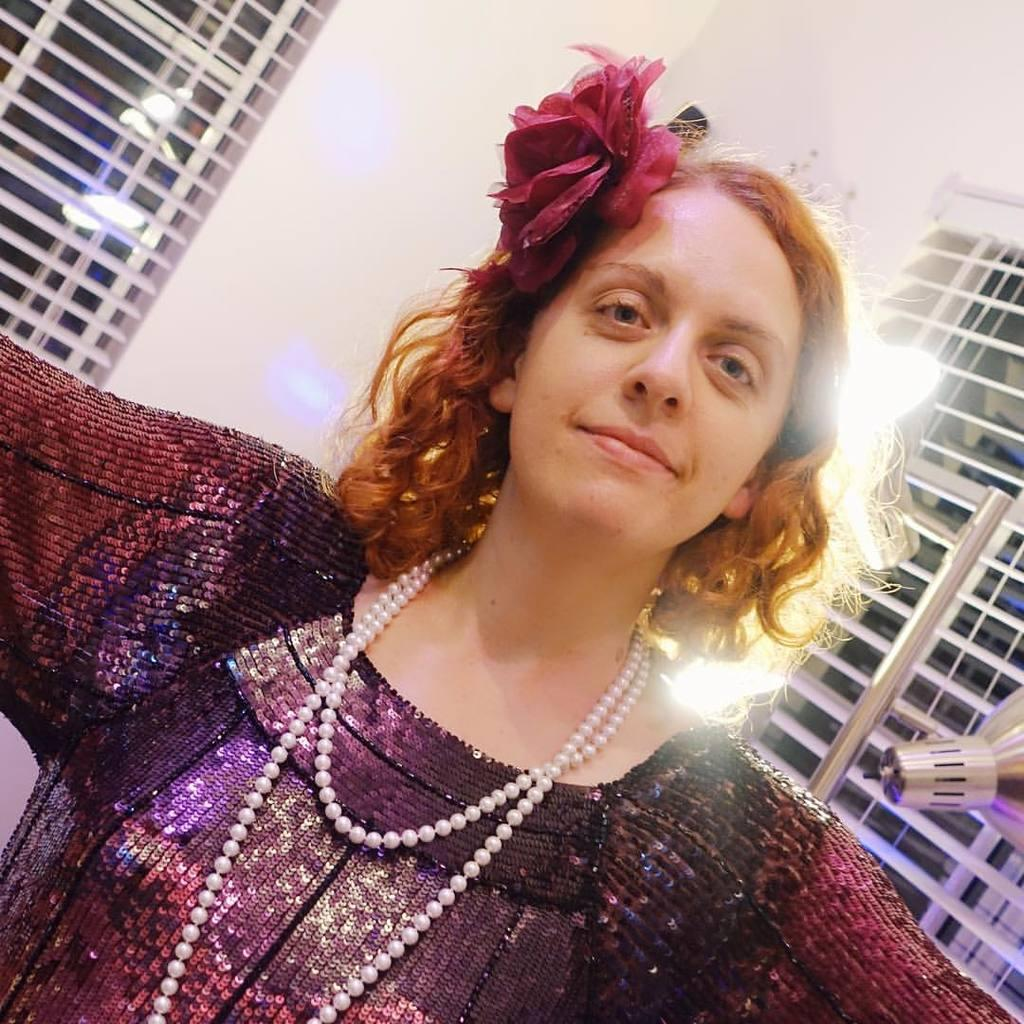What is the main subject of the image? The main subject of the image is a woman. What is the woman wearing in the image? The woman is wearing a dress, a pearls chain, and a head wear in the image. What is the woman doing in the image? The woman is standing and smiling in the image. What can be seen in the background of the image? There are lights and windows in the background of the image. What type of spark can be seen coming from the woman's head wear in the image? There is no spark visible coming from the woman's head wear in the image. 